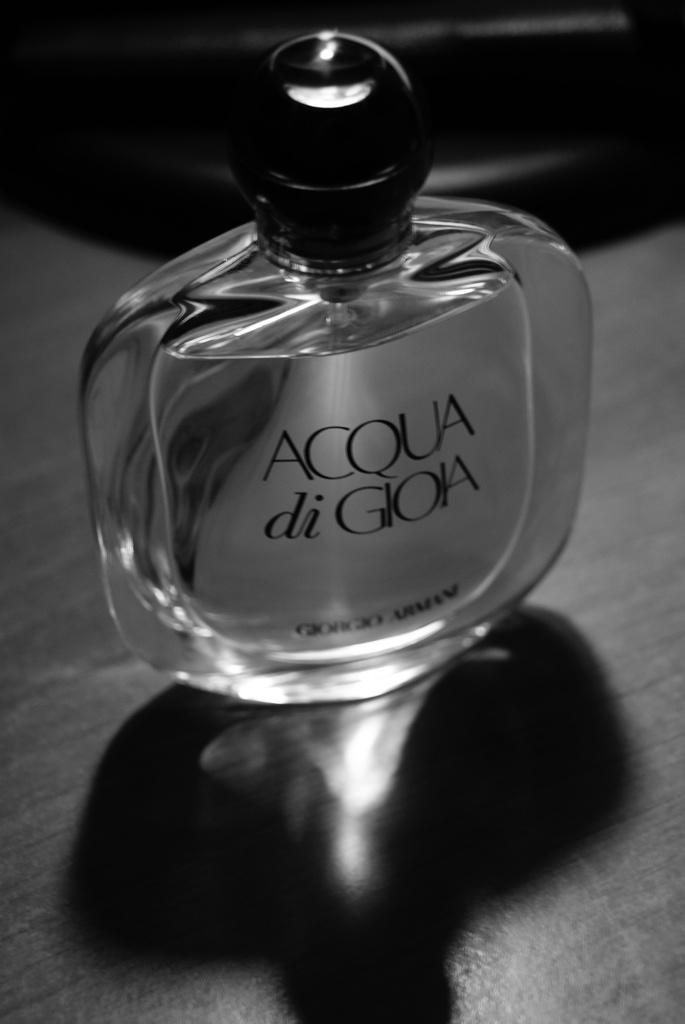Provide a one-sentence caption for the provided image. A bottle of Acqua di Gioia cologne on a wooden table. 